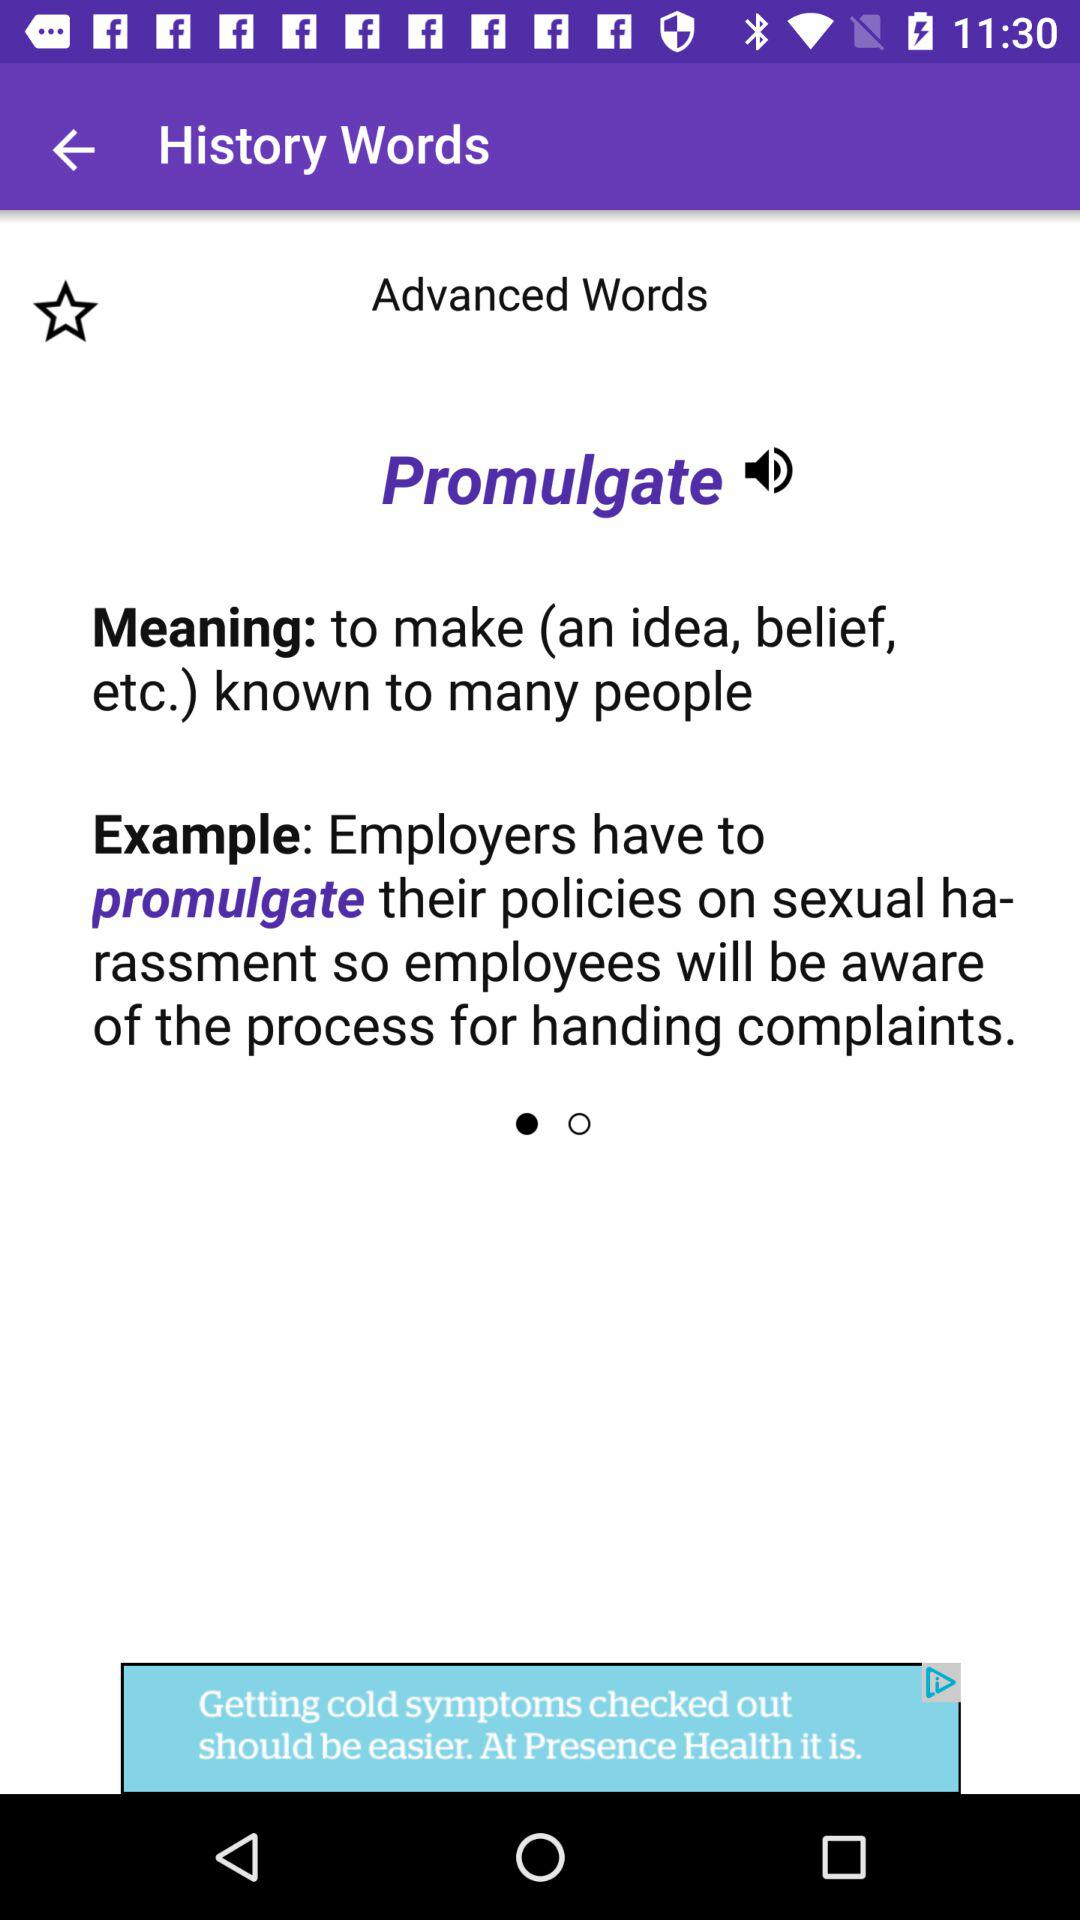What are the synonyms of the word "Promulgate"?
When the provided information is insufficient, respond with <no answer>. <no answer> 